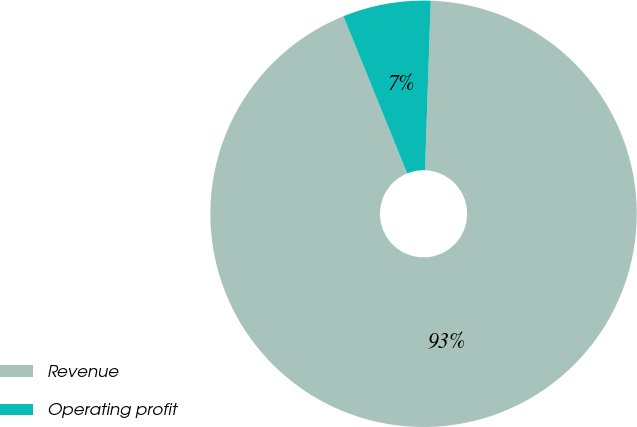Convert chart. <chart><loc_0><loc_0><loc_500><loc_500><pie_chart><fcel>Revenue<fcel>Operating profit<nl><fcel>93.33%<fcel>6.67%<nl></chart> 